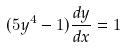<formula> <loc_0><loc_0><loc_500><loc_500>( 5 y ^ { 4 } - 1 ) \frac { d y } { d x } = 1</formula> 